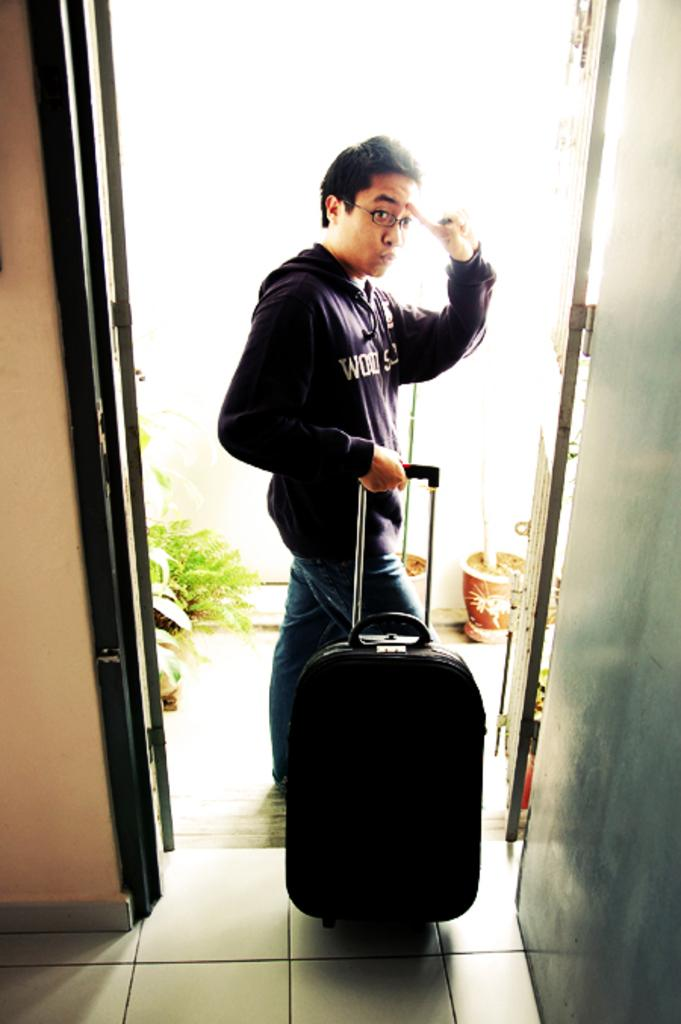What is the main subject of the image? There is a person standing in the center of the image. What is the person holding in his hand? The person is holding a bag in his hand. What other objects can be seen in the image? There is a clay pot and plants in the image. What type of plastic material can be seen in the image? There is no plastic material present in the image. How many friends are standing with the person in the image? There is no mention of friends in the image; only one person is visible. 